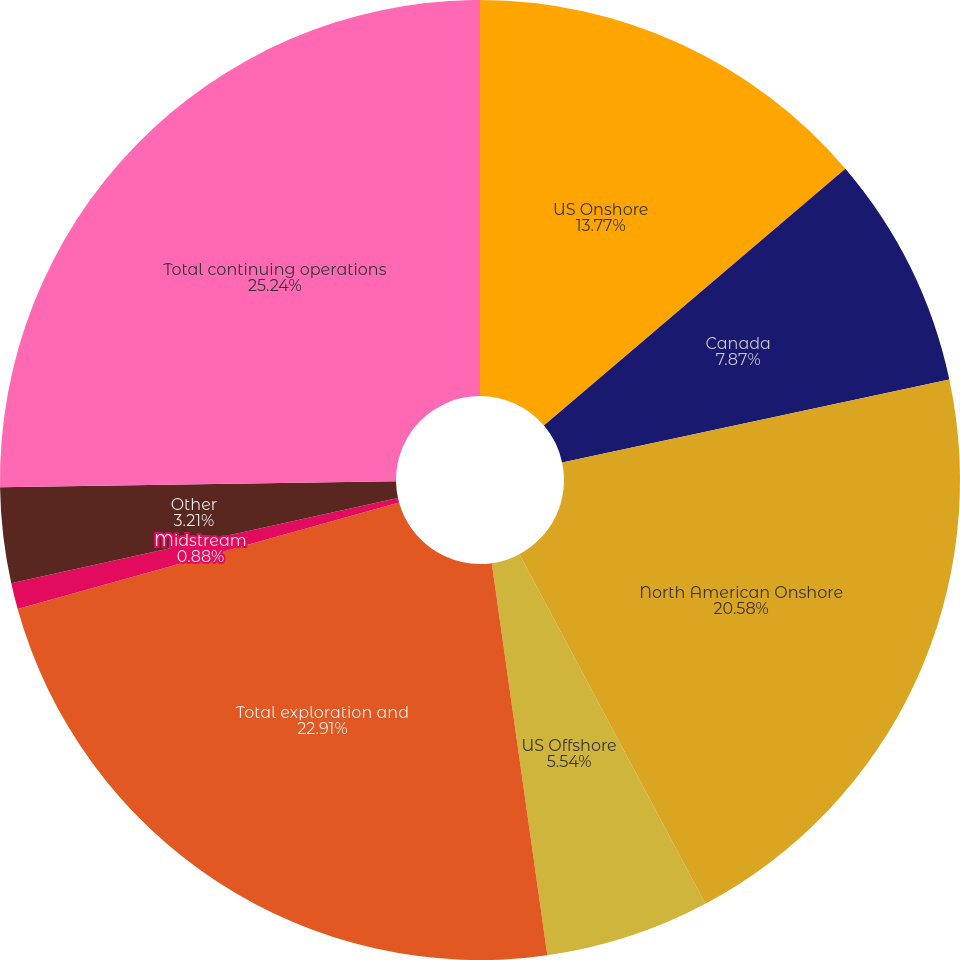<chart> <loc_0><loc_0><loc_500><loc_500><pie_chart><fcel>US Onshore<fcel>Canada<fcel>North American Onshore<fcel>US Offshore<fcel>Total exploration and<fcel>Midstream<fcel>Other<fcel>Total continuing operations<nl><fcel>13.77%<fcel>7.87%<fcel>20.58%<fcel>5.54%<fcel>22.91%<fcel>0.88%<fcel>3.21%<fcel>25.24%<nl></chart> 